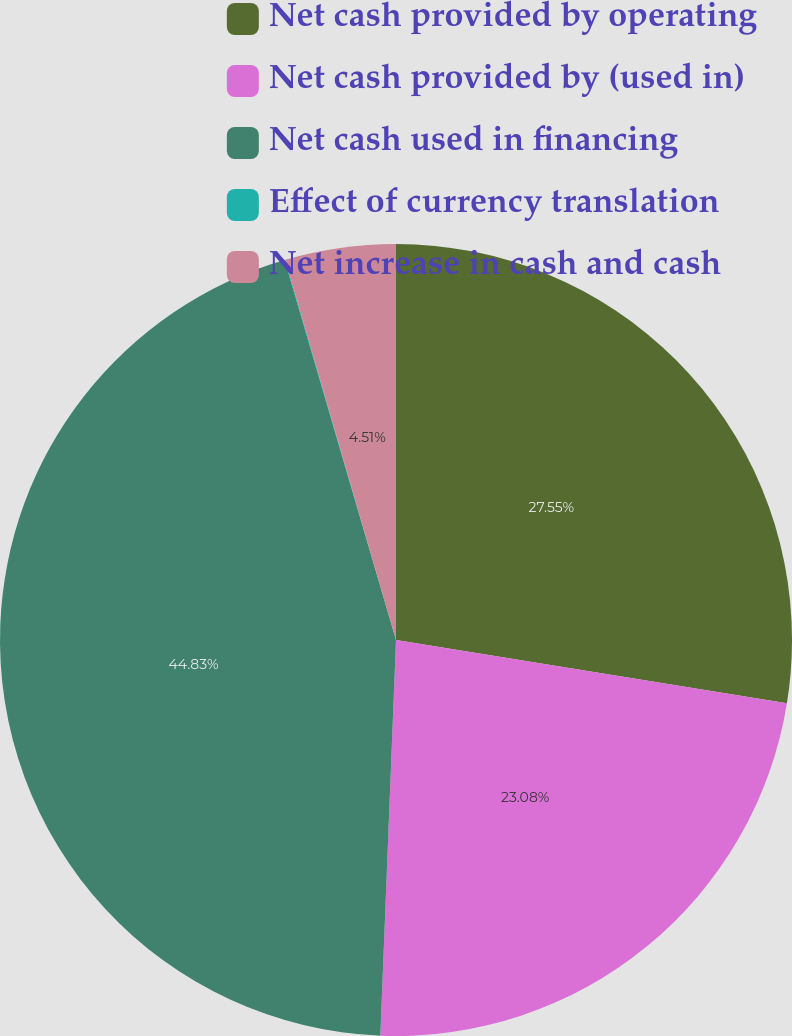Convert chart to OTSL. <chart><loc_0><loc_0><loc_500><loc_500><pie_chart><fcel>Net cash provided by operating<fcel>Net cash provided by (used in)<fcel>Net cash used in financing<fcel>Effect of currency translation<fcel>Net increase in cash and cash<nl><fcel>27.56%<fcel>23.08%<fcel>44.84%<fcel>0.03%<fcel>4.51%<nl></chart> 